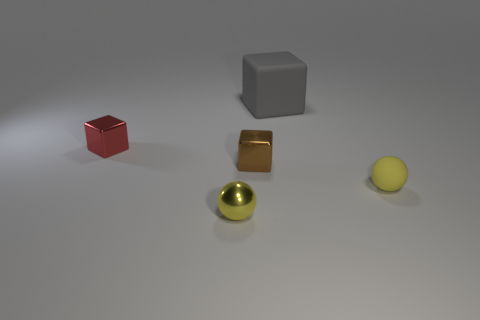There is a shiny thing that is the same color as the small rubber object; what is its shape?
Make the answer very short. Sphere. What size is the gray thing that is the same shape as the red metallic object?
Provide a succinct answer. Large. There is a small cube that is in front of the small red metal cube; what is it made of?
Give a very brief answer. Metal. Is the number of brown blocks behind the gray thing less than the number of big purple matte things?
Offer a terse response. No. The tiny yellow object that is on the left side of the tiny object on the right side of the gray thing is what shape?
Offer a terse response. Sphere. What color is the big cube?
Provide a succinct answer. Gray. How many other objects are the same size as the brown cube?
Your answer should be very brief. 3. What is the tiny object that is on the left side of the tiny brown cube and behind the small yellow matte sphere made of?
Your response must be concise. Metal. There is a shiny object in front of the brown block; does it have the same size as the gray thing?
Provide a succinct answer. No. Is the color of the rubber ball the same as the tiny metal ball?
Provide a short and direct response. Yes. 